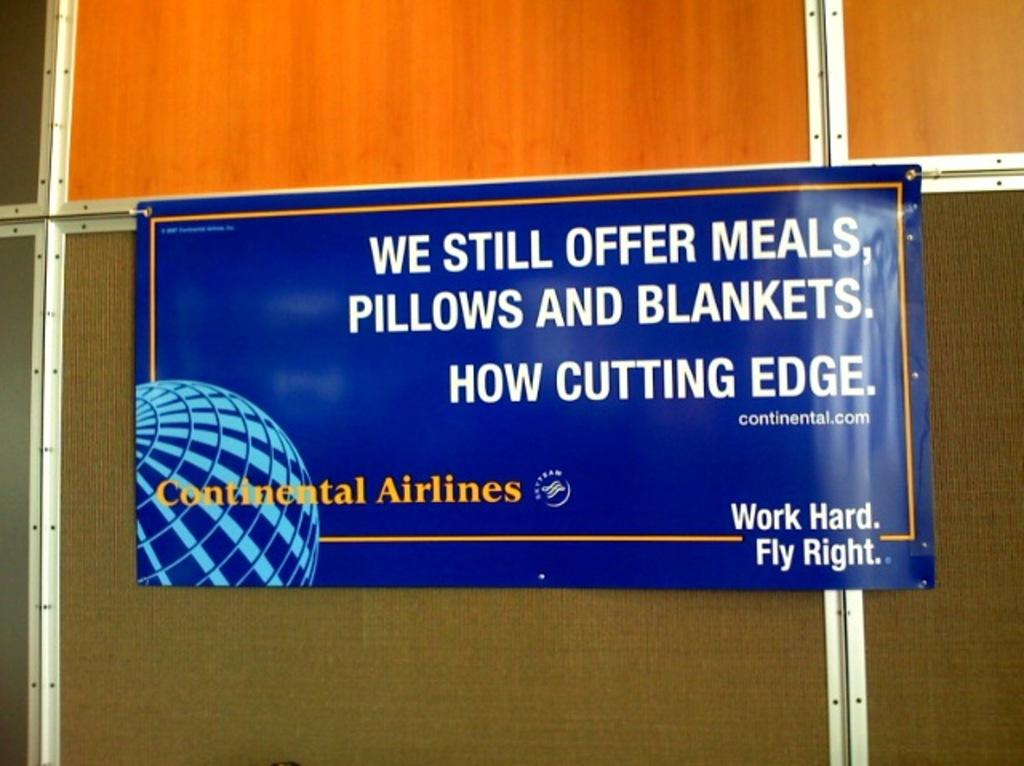<image>
Summarize the visual content of the image. A blue sign that says Continental Airlines is nailed to a wall. 